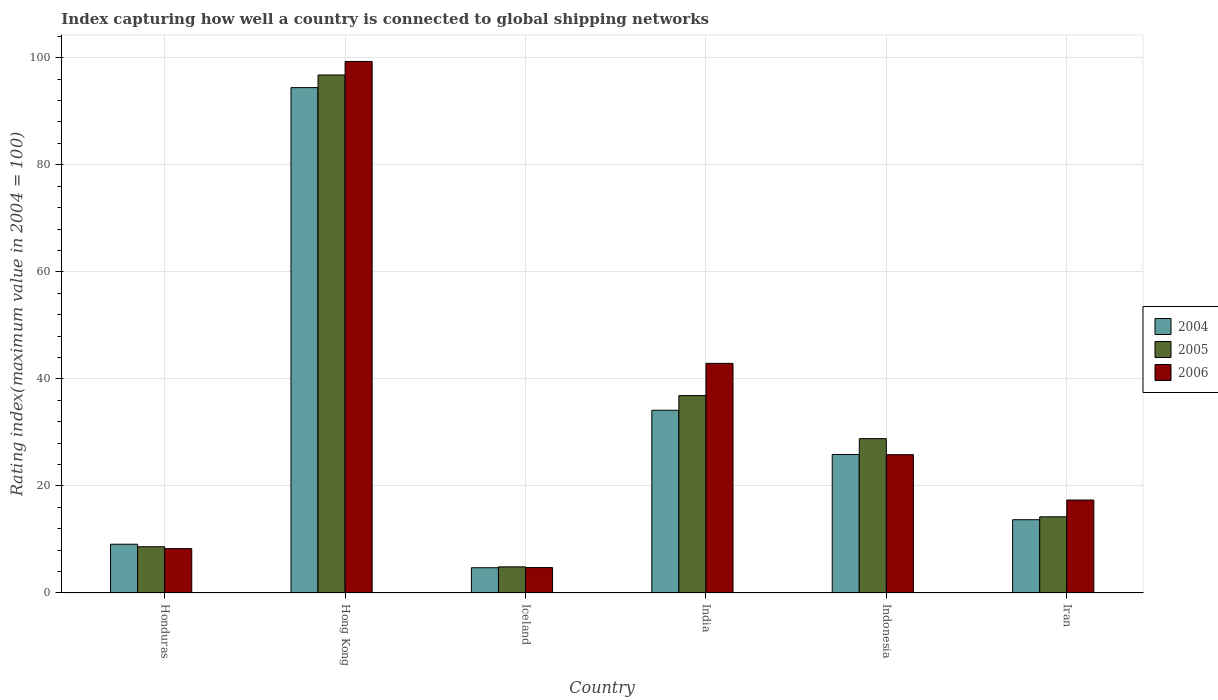How many groups of bars are there?
Offer a terse response. 6. Are the number of bars per tick equal to the number of legend labels?
Offer a very short reply. Yes. What is the label of the 2nd group of bars from the left?
Offer a terse response. Hong Kong. What is the rating index in 2004 in Indonesia?
Provide a short and direct response. 25.88. Across all countries, what is the maximum rating index in 2005?
Provide a succinct answer. 96.78. Across all countries, what is the minimum rating index in 2006?
Your answer should be very brief. 4.75. In which country was the rating index in 2004 maximum?
Your answer should be compact. Hong Kong. What is the total rating index in 2004 in the graph?
Keep it short and to the point. 181.96. What is the difference between the rating index in 2005 in Honduras and that in India?
Give a very brief answer. -28.24. What is the difference between the rating index in 2004 in Indonesia and the rating index in 2006 in Iran?
Your answer should be compact. 8.51. What is the average rating index in 2006 per country?
Your response must be concise. 33.08. What is the difference between the rating index of/in 2006 and rating index of/in 2005 in India?
Offer a terse response. 6.02. In how many countries, is the rating index in 2005 greater than 52?
Make the answer very short. 1. What is the ratio of the rating index in 2005 in Hong Kong to that in India?
Your answer should be very brief. 2.62. Is the rating index in 2004 in Honduras less than that in Indonesia?
Make the answer very short. Yes. What is the difference between the highest and the second highest rating index in 2004?
Keep it short and to the point. -8.26. What is the difference between the highest and the lowest rating index in 2004?
Your response must be concise. 89.7. In how many countries, is the rating index in 2006 greater than the average rating index in 2006 taken over all countries?
Your response must be concise. 2. Is the sum of the rating index in 2004 in India and Iran greater than the maximum rating index in 2005 across all countries?
Provide a succinct answer. No. What does the 2nd bar from the left in Indonesia represents?
Keep it short and to the point. 2005. What does the 2nd bar from the right in Hong Kong represents?
Make the answer very short. 2005. Is it the case that in every country, the sum of the rating index in 2006 and rating index in 2004 is greater than the rating index in 2005?
Your response must be concise. Yes. How many bars are there?
Make the answer very short. 18. How many countries are there in the graph?
Offer a very short reply. 6. Does the graph contain any zero values?
Keep it short and to the point. No. Does the graph contain grids?
Provide a succinct answer. Yes. How are the legend labels stacked?
Make the answer very short. Vertical. What is the title of the graph?
Provide a succinct answer. Index capturing how well a country is connected to global shipping networks. Does "2003" appear as one of the legend labels in the graph?
Provide a succinct answer. No. What is the label or title of the Y-axis?
Your response must be concise. Rating index(maximum value in 2004 = 100). What is the Rating index(maximum value in 2004 = 100) in 2004 in Honduras?
Keep it short and to the point. 9.11. What is the Rating index(maximum value in 2004 = 100) in 2005 in Honduras?
Provide a short and direct response. 8.64. What is the Rating index(maximum value in 2004 = 100) of 2006 in Honduras?
Your response must be concise. 8.29. What is the Rating index(maximum value in 2004 = 100) of 2004 in Hong Kong?
Provide a succinct answer. 94.42. What is the Rating index(maximum value in 2004 = 100) of 2005 in Hong Kong?
Your answer should be compact. 96.78. What is the Rating index(maximum value in 2004 = 100) in 2006 in Hong Kong?
Your answer should be very brief. 99.31. What is the Rating index(maximum value in 2004 = 100) of 2004 in Iceland?
Provide a short and direct response. 4.72. What is the Rating index(maximum value in 2004 = 100) of 2005 in Iceland?
Keep it short and to the point. 4.88. What is the Rating index(maximum value in 2004 = 100) in 2006 in Iceland?
Keep it short and to the point. 4.75. What is the Rating index(maximum value in 2004 = 100) in 2004 in India?
Provide a short and direct response. 34.14. What is the Rating index(maximum value in 2004 = 100) in 2005 in India?
Provide a short and direct response. 36.88. What is the Rating index(maximum value in 2004 = 100) of 2006 in India?
Give a very brief answer. 42.9. What is the Rating index(maximum value in 2004 = 100) in 2004 in Indonesia?
Your answer should be compact. 25.88. What is the Rating index(maximum value in 2004 = 100) in 2005 in Indonesia?
Keep it short and to the point. 28.84. What is the Rating index(maximum value in 2004 = 100) in 2006 in Indonesia?
Offer a terse response. 25.84. What is the Rating index(maximum value in 2004 = 100) in 2004 in Iran?
Your response must be concise. 13.69. What is the Rating index(maximum value in 2004 = 100) of 2005 in Iran?
Ensure brevity in your answer.  14.23. What is the Rating index(maximum value in 2004 = 100) in 2006 in Iran?
Offer a very short reply. 17.37. Across all countries, what is the maximum Rating index(maximum value in 2004 = 100) of 2004?
Provide a short and direct response. 94.42. Across all countries, what is the maximum Rating index(maximum value in 2004 = 100) of 2005?
Keep it short and to the point. 96.78. Across all countries, what is the maximum Rating index(maximum value in 2004 = 100) of 2006?
Your answer should be very brief. 99.31. Across all countries, what is the minimum Rating index(maximum value in 2004 = 100) of 2004?
Your answer should be compact. 4.72. Across all countries, what is the minimum Rating index(maximum value in 2004 = 100) in 2005?
Keep it short and to the point. 4.88. Across all countries, what is the minimum Rating index(maximum value in 2004 = 100) in 2006?
Ensure brevity in your answer.  4.75. What is the total Rating index(maximum value in 2004 = 100) of 2004 in the graph?
Provide a succinct answer. 181.96. What is the total Rating index(maximum value in 2004 = 100) in 2005 in the graph?
Provide a succinct answer. 190.25. What is the total Rating index(maximum value in 2004 = 100) of 2006 in the graph?
Keep it short and to the point. 198.46. What is the difference between the Rating index(maximum value in 2004 = 100) in 2004 in Honduras and that in Hong Kong?
Your response must be concise. -85.31. What is the difference between the Rating index(maximum value in 2004 = 100) of 2005 in Honduras and that in Hong Kong?
Keep it short and to the point. -88.14. What is the difference between the Rating index(maximum value in 2004 = 100) in 2006 in Honduras and that in Hong Kong?
Give a very brief answer. -91.02. What is the difference between the Rating index(maximum value in 2004 = 100) in 2004 in Honduras and that in Iceland?
Offer a terse response. 4.39. What is the difference between the Rating index(maximum value in 2004 = 100) in 2005 in Honduras and that in Iceland?
Keep it short and to the point. 3.76. What is the difference between the Rating index(maximum value in 2004 = 100) in 2006 in Honduras and that in Iceland?
Make the answer very short. 3.54. What is the difference between the Rating index(maximum value in 2004 = 100) of 2004 in Honduras and that in India?
Offer a very short reply. -25.03. What is the difference between the Rating index(maximum value in 2004 = 100) in 2005 in Honduras and that in India?
Keep it short and to the point. -28.24. What is the difference between the Rating index(maximum value in 2004 = 100) in 2006 in Honduras and that in India?
Make the answer very short. -34.61. What is the difference between the Rating index(maximum value in 2004 = 100) in 2004 in Honduras and that in Indonesia?
Make the answer very short. -16.77. What is the difference between the Rating index(maximum value in 2004 = 100) of 2005 in Honduras and that in Indonesia?
Provide a succinct answer. -20.2. What is the difference between the Rating index(maximum value in 2004 = 100) in 2006 in Honduras and that in Indonesia?
Your answer should be very brief. -17.55. What is the difference between the Rating index(maximum value in 2004 = 100) in 2004 in Honduras and that in Iran?
Give a very brief answer. -4.58. What is the difference between the Rating index(maximum value in 2004 = 100) in 2005 in Honduras and that in Iran?
Provide a succinct answer. -5.59. What is the difference between the Rating index(maximum value in 2004 = 100) in 2006 in Honduras and that in Iran?
Your answer should be compact. -9.08. What is the difference between the Rating index(maximum value in 2004 = 100) of 2004 in Hong Kong and that in Iceland?
Give a very brief answer. 89.7. What is the difference between the Rating index(maximum value in 2004 = 100) in 2005 in Hong Kong and that in Iceland?
Offer a terse response. 91.9. What is the difference between the Rating index(maximum value in 2004 = 100) in 2006 in Hong Kong and that in Iceland?
Make the answer very short. 94.56. What is the difference between the Rating index(maximum value in 2004 = 100) in 2004 in Hong Kong and that in India?
Provide a succinct answer. 60.28. What is the difference between the Rating index(maximum value in 2004 = 100) in 2005 in Hong Kong and that in India?
Offer a terse response. 59.9. What is the difference between the Rating index(maximum value in 2004 = 100) of 2006 in Hong Kong and that in India?
Your answer should be very brief. 56.41. What is the difference between the Rating index(maximum value in 2004 = 100) in 2004 in Hong Kong and that in Indonesia?
Keep it short and to the point. 68.54. What is the difference between the Rating index(maximum value in 2004 = 100) of 2005 in Hong Kong and that in Indonesia?
Make the answer very short. 67.94. What is the difference between the Rating index(maximum value in 2004 = 100) of 2006 in Hong Kong and that in Indonesia?
Your response must be concise. 73.47. What is the difference between the Rating index(maximum value in 2004 = 100) in 2004 in Hong Kong and that in Iran?
Give a very brief answer. 80.73. What is the difference between the Rating index(maximum value in 2004 = 100) of 2005 in Hong Kong and that in Iran?
Make the answer very short. 82.55. What is the difference between the Rating index(maximum value in 2004 = 100) in 2006 in Hong Kong and that in Iran?
Provide a succinct answer. 81.94. What is the difference between the Rating index(maximum value in 2004 = 100) in 2004 in Iceland and that in India?
Keep it short and to the point. -29.42. What is the difference between the Rating index(maximum value in 2004 = 100) in 2005 in Iceland and that in India?
Offer a terse response. -32. What is the difference between the Rating index(maximum value in 2004 = 100) in 2006 in Iceland and that in India?
Give a very brief answer. -38.15. What is the difference between the Rating index(maximum value in 2004 = 100) of 2004 in Iceland and that in Indonesia?
Offer a terse response. -21.16. What is the difference between the Rating index(maximum value in 2004 = 100) in 2005 in Iceland and that in Indonesia?
Provide a short and direct response. -23.96. What is the difference between the Rating index(maximum value in 2004 = 100) in 2006 in Iceland and that in Indonesia?
Ensure brevity in your answer.  -21.09. What is the difference between the Rating index(maximum value in 2004 = 100) in 2004 in Iceland and that in Iran?
Your answer should be compact. -8.97. What is the difference between the Rating index(maximum value in 2004 = 100) of 2005 in Iceland and that in Iran?
Your answer should be very brief. -9.35. What is the difference between the Rating index(maximum value in 2004 = 100) of 2006 in Iceland and that in Iran?
Offer a terse response. -12.62. What is the difference between the Rating index(maximum value in 2004 = 100) of 2004 in India and that in Indonesia?
Offer a very short reply. 8.26. What is the difference between the Rating index(maximum value in 2004 = 100) in 2005 in India and that in Indonesia?
Your response must be concise. 8.04. What is the difference between the Rating index(maximum value in 2004 = 100) of 2006 in India and that in Indonesia?
Offer a terse response. 17.06. What is the difference between the Rating index(maximum value in 2004 = 100) in 2004 in India and that in Iran?
Give a very brief answer. 20.45. What is the difference between the Rating index(maximum value in 2004 = 100) in 2005 in India and that in Iran?
Make the answer very short. 22.65. What is the difference between the Rating index(maximum value in 2004 = 100) of 2006 in India and that in Iran?
Your answer should be compact. 25.53. What is the difference between the Rating index(maximum value in 2004 = 100) of 2004 in Indonesia and that in Iran?
Make the answer very short. 12.19. What is the difference between the Rating index(maximum value in 2004 = 100) of 2005 in Indonesia and that in Iran?
Give a very brief answer. 14.61. What is the difference between the Rating index(maximum value in 2004 = 100) in 2006 in Indonesia and that in Iran?
Offer a terse response. 8.47. What is the difference between the Rating index(maximum value in 2004 = 100) in 2004 in Honduras and the Rating index(maximum value in 2004 = 100) in 2005 in Hong Kong?
Keep it short and to the point. -87.67. What is the difference between the Rating index(maximum value in 2004 = 100) in 2004 in Honduras and the Rating index(maximum value in 2004 = 100) in 2006 in Hong Kong?
Your answer should be very brief. -90.2. What is the difference between the Rating index(maximum value in 2004 = 100) of 2005 in Honduras and the Rating index(maximum value in 2004 = 100) of 2006 in Hong Kong?
Provide a short and direct response. -90.67. What is the difference between the Rating index(maximum value in 2004 = 100) in 2004 in Honduras and the Rating index(maximum value in 2004 = 100) in 2005 in Iceland?
Make the answer very short. 4.23. What is the difference between the Rating index(maximum value in 2004 = 100) in 2004 in Honduras and the Rating index(maximum value in 2004 = 100) in 2006 in Iceland?
Provide a succinct answer. 4.36. What is the difference between the Rating index(maximum value in 2004 = 100) in 2005 in Honduras and the Rating index(maximum value in 2004 = 100) in 2006 in Iceland?
Give a very brief answer. 3.89. What is the difference between the Rating index(maximum value in 2004 = 100) in 2004 in Honduras and the Rating index(maximum value in 2004 = 100) in 2005 in India?
Offer a very short reply. -27.77. What is the difference between the Rating index(maximum value in 2004 = 100) in 2004 in Honduras and the Rating index(maximum value in 2004 = 100) in 2006 in India?
Provide a short and direct response. -33.79. What is the difference between the Rating index(maximum value in 2004 = 100) of 2005 in Honduras and the Rating index(maximum value in 2004 = 100) of 2006 in India?
Keep it short and to the point. -34.26. What is the difference between the Rating index(maximum value in 2004 = 100) in 2004 in Honduras and the Rating index(maximum value in 2004 = 100) in 2005 in Indonesia?
Ensure brevity in your answer.  -19.73. What is the difference between the Rating index(maximum value in 2004 = 100) of 2004 in Honduras and the Rating index(maximum value in 2004 = 100) of 2006 in Indonesia?
Provide a succinct answer. -16.73. What is the difference between the Rating index(maximum value in 2004 = 100) in 2005 in Honduras and the Rating index(maximum value in 2004 = 100) in 2006 in Indonesia?
Keep it short and to the point. -17.2. What is the difference between the Rating index(maximum value in 2004 = 100) of 2004 in Honduras and the Rating index(maximum value in 2004 = 100) of 2005 in Iran?
Provide a succinct answer. -5.12. What is the difference between the Rating index(maximum value in 2004 = 100) of 2004 in Honduras and the Rating index(maximum value in 2004 = 100) of 2006 in Iran?
Make the answer very short. -8.26. What is the difference between the Rating index(maximum value in 2004 = 100) of 2005 in Honduras and the Rating index(maximum value in 2004 = 100) of 2006 in Iran?
Your answer should be very brief. -8.73. What is the difference between the Rating index(maximum value in 2004 = 100) of 2004 in Hong Kong and the Rating index(maximum value in 2004 = 100) of 2005 in Iceland?
Ensure brevity in your answer.  89.54. What is the difference between the Rating index(maximum value in 2004 = 100) in 2004 in Hong Kong and the Rating index(maximum value in 2004 = 100) in 2006 in Iceland?
Provide a succinct answer. 89.67. What is the difference between the Rating index(maximum value in 2004 = 100) of 2005 in Hong Kong and the Rating index(maximum value in 2004 = 100) of 2006 in Iceland?
Make the answer very short. 92.03. What is the difference between the Rating index(maximum value in 2004 = 100) of 2004 in Hong Kong and the Rating index(maximum value in 2004 = 100) of 2005 in India?
Give a very brief answer. 57.54. What is the difference between the Rating index(maximum value in 2004 = 100) of 2004 in Hong Kong and the Rating index(maximum value in 2004 = 100) of 2006 in India?
Your response must be concise. 51.52. What is the difference between the Rating index(maximum value in 2004 = 100) in 2005 in Hong Kong and the Rating index(maximum value in 2004 = 100) in 2006 in India?
Offer a terse response. 53.88. What is the difference between the Rating index(maximum value in 2004 = 100) in 2004 in Hong Kong and the Rating index(maximum value in 2004 = 100) in 2005 in Indonesia?
Ensure brevity in your answer.  65.58. What is the difference between the Rating index(maximum value in 2004 = 100) in 2004 in Hong Kong and the Rating index(maximum value in 2004 = 100) in 2006 in Indonesia?
Ensure brevity in your answer.  68.58. What is the difference between the Rating index(maximum value in 2004 = 100) in 2005 in Hong Kong and the Rating index(maximum value in 2004 = 100) in 2006 in Indonesia?
Keep it short and to the point. 70.94. What is the difference between the Rating index(maximum value in 2004 = 100) in 2004 in Hong Kong and the Rating index(maximum value in 2004 = 100) in 2005 in Iran?
Provide a succinct answer. 80.19. What is the difference between the Rating index(maximum value in 2004 = 100) in 2004 in Hong Kong and the Rating index(maximum value in 2004 = 100) in 2006 in Iran?
Offer a very short reply. 77.05. What is the difference between the Rating index(maximum value in 2004 = 100) in 2005 in Hong Kong and the Rating index(maximum value in 2004 = 100) in 2006 in Iran?
Your response must be concise. 79.41. What is the difference between the Rating index(maximum value in 2004 = 100) in 2004 in Iceland and the Rating index(maximum value in 2004 = 100) in 2005 in India?
Offer a terse response. -32.16. What is the difference between the Rating index(maximum value in 2004 = 100) of 2004 in Iceland and the Rating index(maximum value in 2004 = 100) of 2006 in India?
Give a very brief answer. -38.18. What is the difference between the Rating index(maximum value in 2004 = 100) in 2005 in Iceland and the Rating index(maximum value in 2004 = 100) in 2006 in India?
Give a very brief answer. -38.02. What is the difference between the Rating index(maximum value in 2004 = 100) of 2004 in Iceland and the Rating index(maximum value in 2004 = 100) of 2005 in Indonesia?
Your response must be concise. -24.12. What is the difference between the Rating index(maximum value in 2004 = 100) of 2004 in Iceland and the Rating index(maximum value in 2004 = 100) of 2006 in Indonesia?
Your response must be concise. -21.12. What is the difference between the Rating index(maximum value in 2004 = 100) in 2005 in Iceland and the Rating index(maximum value in 2004 = 100) in 2006 in Indonesia?
Offer a terse response. -20.96. What is the difference between the Rating index(maximum value in 2004 = 100) of 2004 in Iceland and the Rating index(maximum value in 2004 = 100) of 2005 in Iran?
Offer a very short reply. -9.51. What is the difference between the Rating index(maximum value in 2004 = 100) of 2004 in Iceland and the Rating index(maximum value in 2004 = 100) of 2006 in Iran?
Offer a terse response. -12.65. What is the difference between the Rating index(maximum value in 2004 = 100) in 2005 in Iceland and the Rating index(maximum value in 2004 = 100) in 2006 in Iran?
Offer a terse response. -12.49. What is the difference between the Rating index(maximum value in 2004 = 100) in 2005 in India and the Rating index(maximum value in 2004 = 100) in 2006 in Indonesia?
Provide a succinct answer. 11.04. What is the difference between the Rating index(maximum value in 2004 = 100) in 2004 in India and the Rating index(maximum value in 2004 = 100) in 2005 in Iran?
Give a very brief answer. 19.91. What is the difference between the Rating index(maximum value in 2004 = 100) of 2004 in India and the Rating index(maximum value in 2004 = 100) of 2006 in Iran?
Provide a short and direct response. 16.77. What is the difference between the Rating index(maximum value in 2004 = 100) of 2005 in India and the Rating index(maximum value in 2004 = 100) of 2006 in Iran?
Keep it short and to the point. 19.51. What is the difference between the Rating index(maximum value in 2004 = 100) of 2004 in Indonesia and the Rating index(maximum value in 2004 = 100) of 2005 in Iran?
Your answer should be compact. 11.65. What is the difference between the Rating index(maximum value in 2004 = 100) in 2004 in Indonesia and the Rating index(maximum value in 2004 = 100) in 2006 in Iran?
Give a very brief answer. 8.51. What is the difference between the Rating index(maximum value in 2004 = 100) in 2005 in Indonesia and the Rating index(maximum value in 2004 = 100) in 2006 in Iran?
Your answer should be very brief. 11.47. What is the average Rating index(maximum value in 2004 = 100) of 2004 per country?
Provide a succinct answer. 30.33. What is the average Rating index(maximum value in 2004 = 100) in 2005 per country?
Provide a succinct answer. 31.71. What is the average Rating index(maximum value in 2004 = 100) in 2006 per country?
Keep it short and to the point. 33.08. What is the difference between the Rating index(maximum value in 2004 = 100) in 2004 and Rating index(maximum value in 2004 = 100) in 2005 in Honduras?
Provide a short and direct response. 0.47. What is the difference between the Rating index(maximum value in 2004 = 100) of 2004 and Rating index(maximum value in 2004 = 100) of 2006 in Honduras?
Make the answer very short. 0.82. What is the difference between the Rating index(maximum value in 2004 = 100) of 2005 and Rating index(maximum value in 2004 = 100) of 2006 in Honduras?
Keep it short and to the point. 0.35. What is the difference between the Rating index(maximum value in 2004 = 100) of 2004 and Rating index(maximum value in 2004 = 100) of 2005 in Hong Kong?
Keep it short and to the point. -2.36. What is the difference between the Rating index(maximum value in 2004 = 100) of 2004 and Rating index(maximum value in 2004 = 100) of 2006 in Hong Kong?
Your answer should be very brief. -4.89. What is the difference between the Rating index(maximum value in 2004 = 100) of 2005 and Rating index(maximum value in 2004 = 100) of 2006 in Hong Kong?
Offer a terse response. -2.53. What is the difference between the Rating index(maximum value in 2004 = 100) of 2004 and Rating index(maximum value in 2004 = 100) of 2005 in Iceland?
Offer a very short reply. -0.16. What is the difference between the Rating index(maximum value in 2004 = 100) in 2004 and Rating index(maximum value in 2004 = 100) in 2006 in Iceland?
Provide a short and direct response. -0.03. What is the difference between the Rating index(maximum value in 2004 = 100) in 2005 and Rating index(maximum value in 2004 = 100) in 2006 in Iceland?
Keep it short and to the point. 0.13. What is the difference between the Rating index(maximum value in 2004 = 100) in 2004 and Rating index(maximum value in 2004 = 100) in 2005 in India?
Your answer should be compact. -2.74. What is the difference between the Rating index(maximum value in 2004 = 100) of 2004 and Rating index(maximum value in 2004 = 100) of 2006 in India?
Offer a very short reply. -8.76. What is the difference between the Rating index(maximum value in 2004 = 100) of 2005 and Rating index(maximum value in 2004 = 100) of 2006 in India?
Ensure brevity in your answer.  -6.02. What is the difference between the Rating index(maximum value in 2004 = 100) in 2004 and Rating index(maximum value in 2004 = 100) in 2005 in Indonesia?
Ensure brevity in your answer.  -2.96. What is the difference between the Rating index(maximum value in 2004 = 100) of 2004 and Rating index(maximum value in 2004 = 100) of 2006 in Indonesia?
Make the answer very short. 0.04. What is the difference between the Rating index(maximum value in 2004 = 100) of 2005 and Rating index(maximum value in 2004 = 100) of 2006 in Indonesia?
Keep it short and to the point. 3. What is the difference between the Rating index(maximum value in 2004 = 100) of 2004 and Rating index(maximum value in 2004 = 100) of 2005 in Iran?
Offer a very short reply. -0.54. What is the difference between the Rating index(maximum value in 2004 = 100) of 2004 and Rating index(maximum value in 2004 = 100) of 2006 in Iran?
Offer a very short reply. -3.68. What is the difference between the Rating index(maximum value in 2004 = 100) in 2005 and Rating index(maximum value in 2004 = 100) in 2006 in Iran?
Your answer should be compact. -3.14. What is the ratio of the Rating index(maximum value in 2004 = 100) of 2004 in Honduras to that in Hong Kong?
Your answer should be very brief. 0.1. What is the ratio of the Rating index(maximum value in 2004 = 100) of 2005 in Honduras to that in Hong Kong?
Your answer should be compact. 0.09. What is the ratio of the Rating index(maximum value in 2004 = 100) of 2006 in Honduras to that in Hong Kong?
Make the answer very short. 0.08. What is the ratio of the Rating index(maximum value in 2004 = 100) of 2004 in Honduras to that in Iceland?
Your response must be concise. 1.93. What is the ratio of the Rating index(maximum value in 2004 = 100) of 2005 in Honduras to that in Iceland?
Make the answer very short. 1.77. What is the ratio of the Rating index(maximum value in 2004 = 100) in 2006 in Honduras to that in Iceland?
Keep it short and to the point. 1.75. What is the ratio of the Rating index(maximum value in 2004 = 100) in 2004 in Honduras to that in India?
Ensure brevity in your answer.  0.27. What is the ratio of the Rating index(maximum value in 2004 = 100) of 2005 in Honduras to that in India?
Your response must be concise. 0.23. What is the ratio of the Rating index(maximum value in 2004 = 100) of 2006 in Honduras to that in India?
Give a very brief answer. 0.19. What is the ratio of the Rating index(maximum value in 2004 = 100) of 2004 in Honduras to that in Indonesia?
Keep it short and to the point. 0.35. What is the ratio of the Rating index(maximum value in 2004 = 100) of 2005 in Honduras to that in Indonesia?
Your response must be concise. 0.3. What is the ratio of the Rating index(maximum value in 2004 = 100) in 2006 in Honduras to that in Indonesia?
Keep it short and to the point. 0.32. What is the ratio of the Rating index(maximum value in 2004 = 100) of 2004 in Honduras to that in Iran?
Ensure brevity in your answer.  0.67. What is the ratio of the Rating index(maximum value in 2004 = 100) of 2005 in Honduras to that in Iran?
Provide a succinct answer. 0.61. What is the ratio of the Rating index(maximum value in 2004 = 100) in 2006 in Honduras to that in Iran?
Your answer should be very brief. 0.48. What is the ratio of the Rating index(maximum value in 2004 = 100) in 2004 in Hong Kong to that in Iceland?
Offer a very short reply. 20. What is the ratio of the Rating index(maximum value in 2004 = 100) in 2005 in Hong Kong to that in Iceland?
Make the answer very short. 19.83. What is the ratio of the Rating index(maximum value in 2004 = 100) in 2006 in Hong Kong to that in Iceland?
Your answer should be compact. 20.91. What is the ratio of the Rating index(maximum value in 2004 = 100) of 2004 in Hong Kong to that in India?
Give a very brief answer. 2.77. What is the ratio of the Rating index(maximum value in 2004 = 100) in 2005 in Hong Kong to that in India?
Provide a short and direct response. 2.62. What is the ratio of the Rating index(maximum value in 2004 = 100) in 2006 in Hong Kong to that in India?
Make the answer very short. 2.31. What is the ratio of the Rating index(maximum value in 2004 = 100) in 2004 in Hong Kong to that in Indonesia?
Keep it short and to the point. 3.65. What is the ratio of the Rating index(maximum value in 2004 = 100) of 2005 in Hong Kong to that in Indonesia?
Your answer should be compact. 3.36. What is the ratio of the Rating index(maximum value in 2004 = 100) of 2006 in Hong Kong to that in Indonesia?
Your answer should be compact. 3.84. What is the ratio of the Rating index(maximum value in 2004 = 100) in 2004 in Hong Kong to that in Iran?
Offer a terse response. 6.9. What is the ratio of the Rating index(maximum value in 2004 = 100) of 2005 in Hong Kong to that in Iran?
Keep it short and to the point. 6.8. What is the ratio of the Rating index(maximum value in 2004 = 100) in 2006 in Hong Kong to that in Iran?
Keep it short and to the point. 5.72. What is the ratio of the Rating index(maximum value in 2004 = 100) of 2004 in Iceland to that in India?
Your answer should be compact. 0.14. What is the ratio of the Rating index(maximum value in 2004 = 100) in 2005 in Iceland to that in India?
Ensure brevity in your answer.  0.13. What is the ratio of the Rating index(maximum value in 2004 = 100) in 2006 in Iceland to that in India?
Offer a very short reply. 0.11. What is the ratio of the Rating index(maximum value in 2004 = 100) of 2004 in Iceland to that in Indonesia?
Make the answer very short. 0.18. What is the ratio of the Rating index(maximum value in 2004 = 100) in 2005 in Iceland to that in Indonesia?
Offer a terse response. 0.17. What is the ratio of the Rating index(maximum value in 2004 = 100) of 2006 in Iceland to that in Indonesia?
Offer a terse response. 0.18. What is the ratio of the Rating index(maximum value in 2004 = 100) of 2004 in Iceland to that in Iran?
Your answer should be compact. 0.34. What is the ratio of the Rating index(maximum value in 2004 = 100) in 2005 in Iceland to that in Iran?
Your answer should be compact. 0.34. What is the ratio of the Rating index(maximum value in 2004 = 100) of 2006 in Iceland to that in Iran?
Ensure brevity in your answer.  0.27. What is the ratio of the Rating index(maximum value in 2004 = 100) in 2004 in India to that in Indonesia?
Give a very brief answer. 1.32. What is the ratio of the Rating index(maximum value in 2004 = 100) in 2005 in India to that in Indonesia?
Your answer should be compact. 1.28. What is the ratio of the Rating index(maximum value in 2004 = 100) of 2006 in India to that in Indonesia?
Provide a succinct answer. 1.66. What is the ratio of the Rating index(maximum value in 2004 = 100) of 2004 in India to that in Iran?
Your response must be concise. 2.49. What is the ratio of the Rating index(maximum value in 2004 = 100) in 2005 in India to that in Iran?
Ensure brevity in your answer.  2.59. What is the ratio of the Rating index(maximum value in 2004 = 100) of 2006 in India to that in Iran?
Offer a terse response. 2.47. What is the ratio of the Rating index(maximum value in 2004 = 100) in 2004 in Indonesia to that in Iran?
Offer a very short reply. 1.89. What is the ratio of the Rating index(maximum value in 2004 = 100) of 2005 in Indonesia to that in Iran?
Give a very brief answer. 2.03. What is the ratio of the Rating index(maximum value in 2004 = 100) in 2006 in Indonesia to that in Iran?
Keep it short and to the point. 1.49. What is the difference between the highest and the second highest Rating index(maximum value in 2004 = 100) of 2004?
Provide a short and direct response. 60.28. What is the difference between the highest and the second highest Rating index(maximum value in 2004 = 100) of 2005?
Keep it short and to the point. 59.9. What is the difference between the highest and the second highest Rating index(maximum value in 2004 = 100) of 2006?
Give a very brief answer. 56.41. What is the difference between the highest and the lowest Rating index(maximum value in 2004 = 100) of 2004?
Keep it short and to the point. 89.7. What is the difference between the highest and the lowest Rating index(maximum value in 2004 = 100) in 2005?
Make the answer very short. 91.9. What is the difference between the highest and the lowest Rating index(maximum value in 2004 = 100) in 2006?
Make the answer very short. 94.56. 